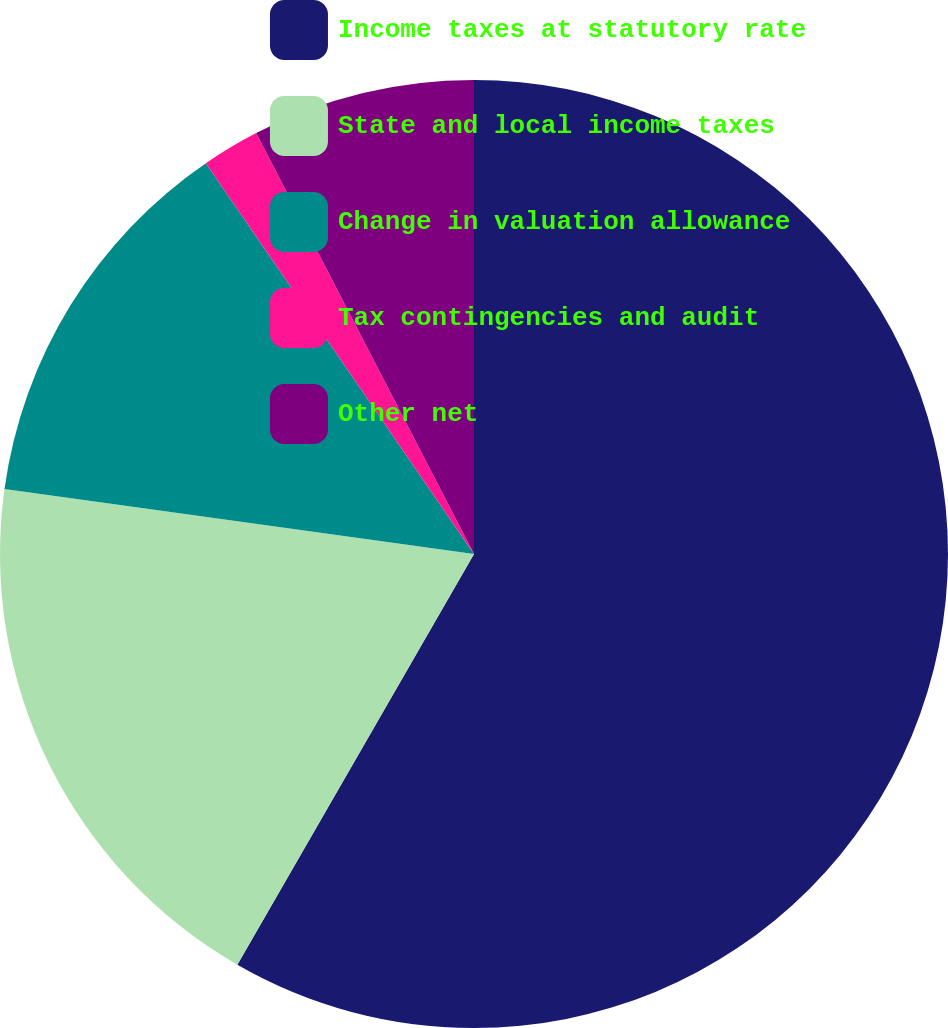<chart> <loc_0><loc_0><loc_500><loc_500><pie_chart><fcel>Income taxes at statutory rate<fcel>State and local income taxes<fcel>Change in valuation allowance<fcel>Tax contingencies and audit<fcel>Other net<nl><fcel>58.32%<fcel>18.87%<fcel>13.24%<fcel>1.97%<fcel>7.6%<nl></chart> 